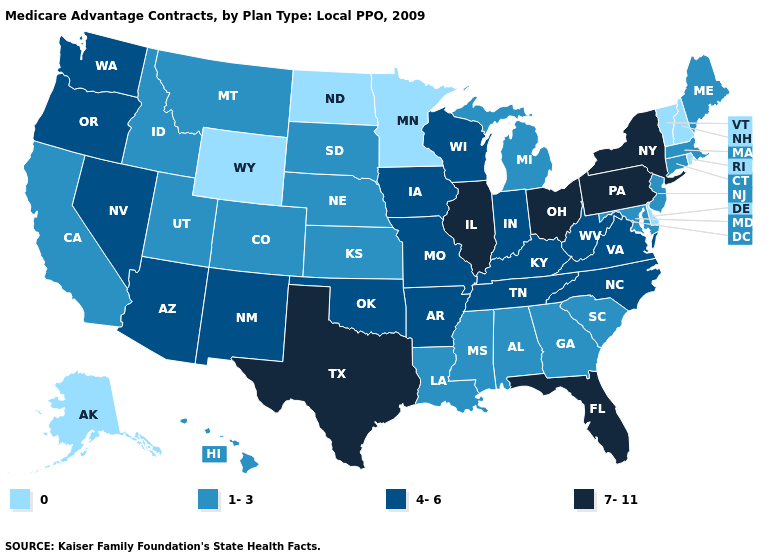What is the highest value in the South ?
Give a very brief answer. 7-11. Name the states that have a value in the range 7-11?
Write a very short answer. Florida, Illinois, New York, Ohio, Pennsylvania, Texas. Name the states that have a value in the range 0?
Answer briefly. Alaska, Delaware, Minnesota, North Dakota, New Hampshire, Rhode Island, Vermont, Wyoming. Does North Dakota have the lowest value in the USA?
Write a very short answer. Yes. Which states have the highest value in the USA?
Be succinct. Florida, Illinois, New York, Ohio, Pennsylvania, Texas. Does Wisconsin have the lowest value in the MidWest?
Answer briefly. No. Name the states that have a value in the range 1-3?
Concise answer only. Alabama, California, Colorado, Connecticut, Georgia, Hawaii, Idaho, Kansas, Louisiana, Massachusetts, Maryland, Maine, Michigan, Mississippi, Montana, Nebraska, New Jersey, South Carolina, South Dakota, Utah. Does Pennsylvania have the lowest value in the Northeast?
Concise answer only. No. Which states have the lowest value in the Northeast?
Give a very brief answer. New Hampshire, Rhode Island, Vermont. Among the states that border Idaho , does Wyoming have the lowest value?
Give a very brief answer. Yes. Name the states that have a value in the range 1-3?
Quick response, please. Alabama, California, Colorado, Connecticut, Georgia, Hawaii, Idaho, Kansas, Louisiana, Massachusetts, Maryland, Maine, Michigan, Mississippi, Montana, Nebraska, New Jersey, South Carolina, South Dakota, Utah. What is the highest value in the USA?
Give a very brief answer. 7-11. What is the highest value in the USA?
Give a very brief answer. 7-11. Which states hav the highest value in the Northeast?
Keep it brief. New York, Pennsylvania. Which states have the highest value in the USA?
Write a very short answer. Florida, Illinois, New York, Ohio, Pennsylvania, Texas. 